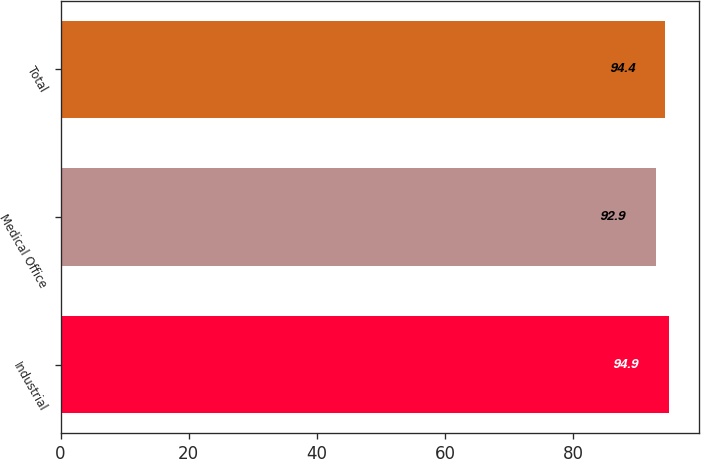Convert chart. <chart><loc_0><loc_0><loc_500><loc_500><bar_chart><fcel>Industrial<fcel>Medical Office<fcel>Total<nl><fcel>94.9<fcel>92.9<fcel>94.4<nl></chart> 